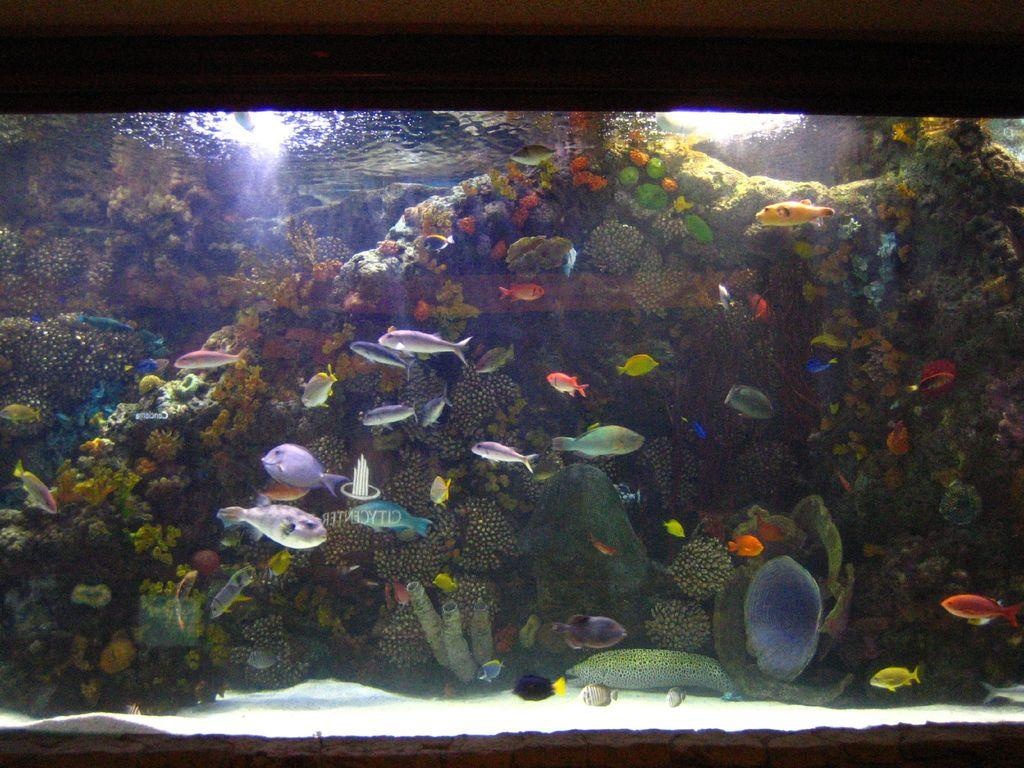What is the main subject of the image? The main subject of the image is an aquarium. What can be seen inside the aquarium? There are different types of fishes moving in the water, as well as corals and reefs visible in the water. What type of noise can be heard coming from the knee in the image? There is no knee present in the image, and therefore no noise can be heard from it. 